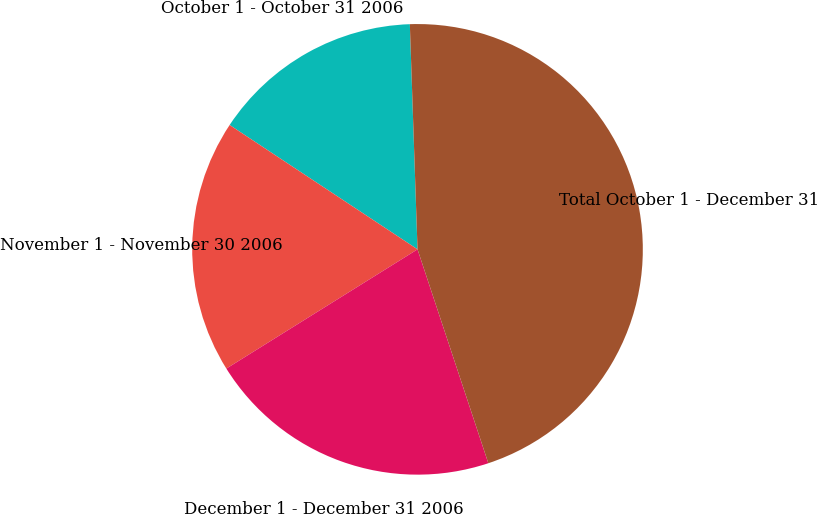Convert chart. <chart><loc_0><loc_0><loc_500><loc_500><pie_chart><fcel>October 1 - October 31 2006<fcel>November 1 - November 30 2006<fcel>December 1 - December 31 2006<fcel>Total October 1 - December 31<nl><fcel>15.15%<fcel>18.18%<fcel>21.21%<fcel>45.45%<nl></chart> 